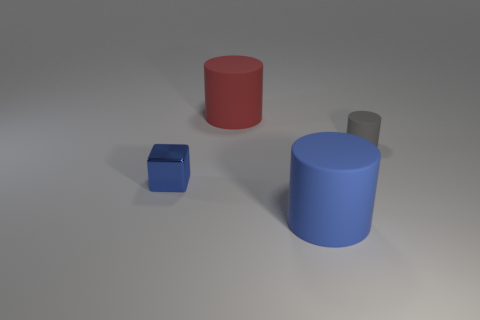Do the rubber thing left of the big blue matte cylinder and the rubber thing in front of the tiny gray object have the same shape?
Provide a short and direct response. Yes. There is a gray thing that is the same shape as the big red object; what size is it?
Give a very brief answer. Small. How many small cylinders are the same material as the big red cylinder?
Make the answer very short. 1. What is the big blue cylinder made of?
Offer a terse response. Rubber. The tiny object that is in front of the tiny thing behind the cube is what shape?
Make the answer very short. Cube. There is a tiny thing that is to the left of the blue rubber cylinder; what is its shape?
Your answer should be very brief. Cube. What number of small cylinders have the same color as the tiny metal cube?
Provide a short and direct response. 0. What is the color of the tiny cylinder?
Offer a terse response. Gray. There is a big matte cylinder that is behind the tiny shiny cube; how many rubber cylinders are in front of it?
Your answer should be very brief. 2. Does the blue cylinder have the same size as the rubber thing behind the small gray rubber thing?
Offer a very short reply. Yes. 